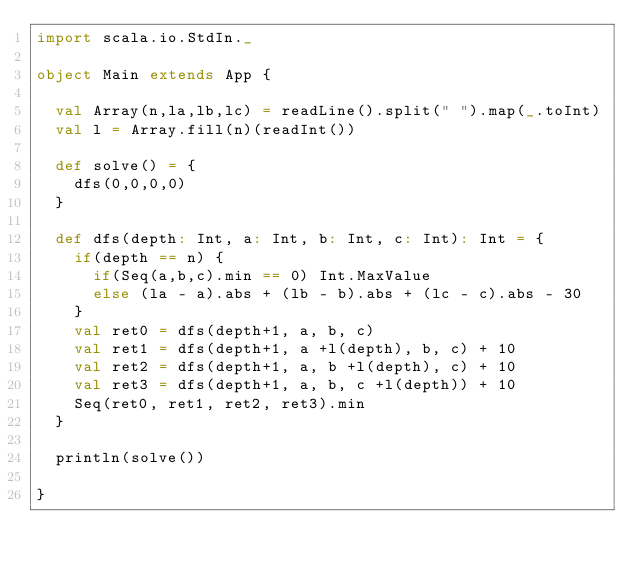Convert code to text. <code><loc_0><loc_0><loc_500><loc_500><_Scala_>import scala.io.StdIn._

object Main extends App {

  val Array(n,la,lb,lc) = readLine().split(" ").map(_.toInt)
  val l = Array.fill(n)(readInt())

  def solve() = {
    dfs(0,0,0,0)
  }

  def dfs(depth: Int, a: Int, b: Int, c: Int): Int = {
    if(depth == n) {
      if(Seq(a,b,c).min == 0) Int.MaxValue
      else (la - a).abs + (lb - b).abs + (lc - c).abs - 30
    }
    val ret0 = dfs(depth+1, a, b, c)
    val ret1 = dfs(depth+1, a +l(depth), b, c) + 10
    val ret2 = dfs(depth+1, a, b +l(depth), c) + 10
    val ret3 = dfs(depth+1, a, b, c +l(depth)) + 10
    Seq(ret0, ret1, ret2, ret3).min
  }

  println(solve())

}

</code> 